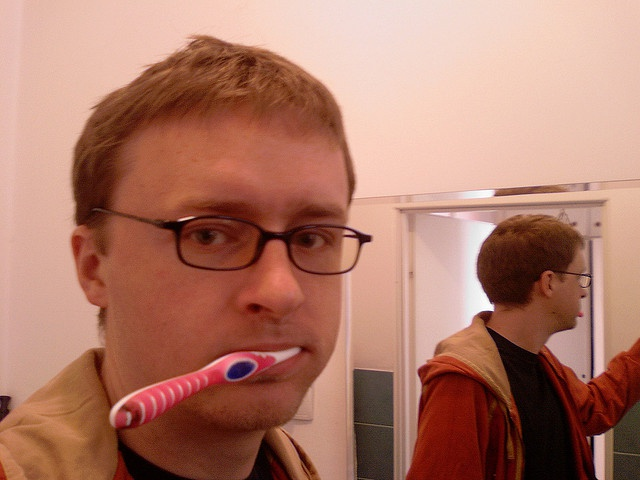Describe the objects in this image and their specific colors. I can see people in pink, brown, and maroon tones, people in pink, maroon, black, and brown tones, and toothbrush in pink, salmon, brown, and lightpink tones in this image. 